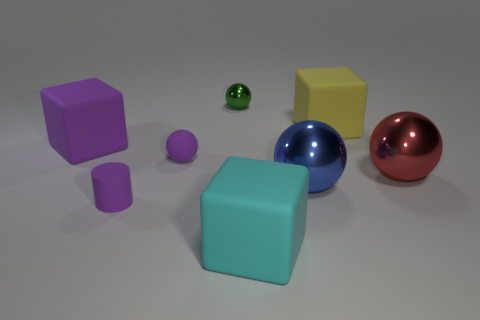Which object appears to be in the foreground? The cyan cube appears to be the most prominent object in the foreground due to its central position and size relative to other objects in the image. Is there a size progression among the objects? Yes, there seems to be a size progression from smaller to larger objects. The very small purple sphere is the smallest, followed by the small green glossy sphere. The objects increment in size up to the large cubes and large shiny spheres. 